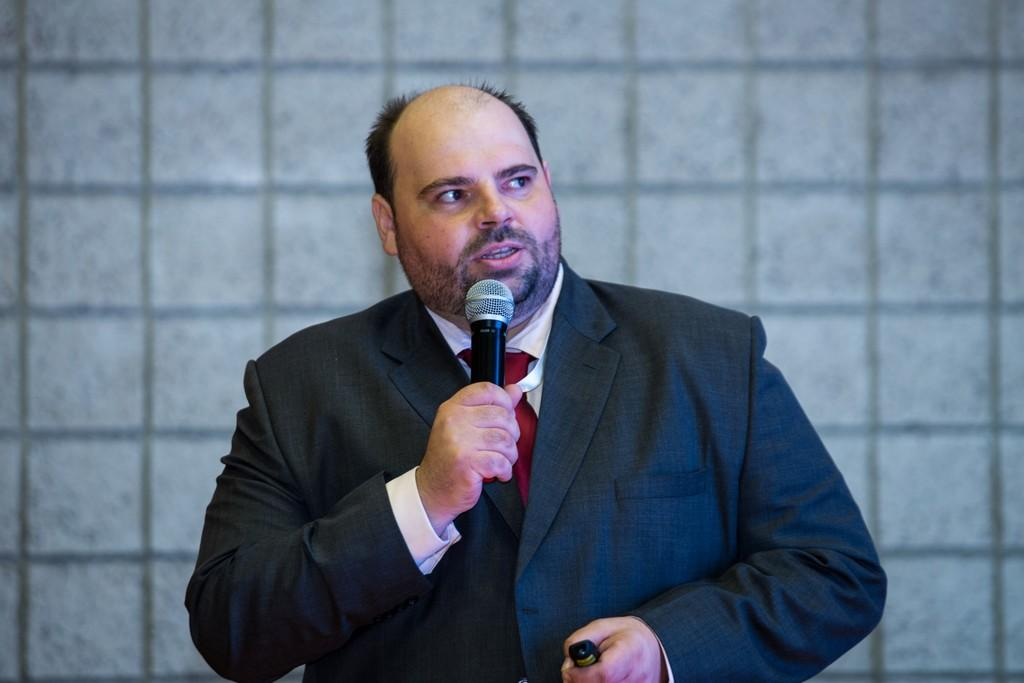Who is the main subject in the image? There is a man in the image. What is the man wearing? The man is wearing a blazer. What object is the man holding in his hand? The man is holding a microphone in his hand. What is the man doing in the image? The man is talking. What type of pain is the man experiencing in the image? There is no indication of pain in the image; the man is talking while holding a microphone. 